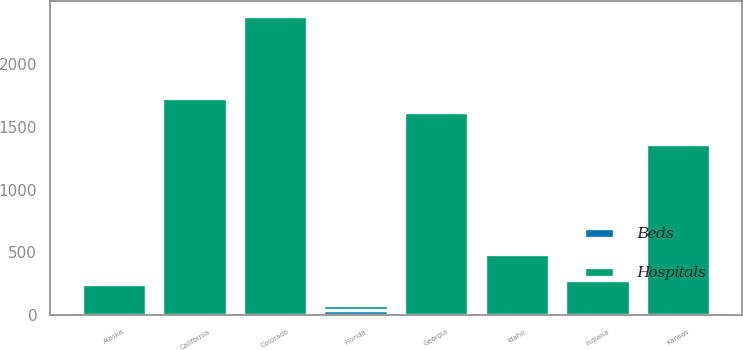<chart> <loc_0><loc_0><loc_500><loc_500><stacked_bar_chart><ecel><fcel>Alaska<fcel>California<fcel>Colorado<fcel>Florida<fcel>Georgia<fcel>Idaho<fcel>Indiana<fcel>Kansas<nl><fcel>Beds<fcel>1<fcel>5<fcel>7<fcel>43<fcel>7<fcel>2<fcel>1<fcel>4<nl><fcel>Hospitals<fcel>250<fcel>1725<fcel>2371<fcel>43<fcel>1609<fcel>484<fcel>278<fcel>1360<nl></chart> 